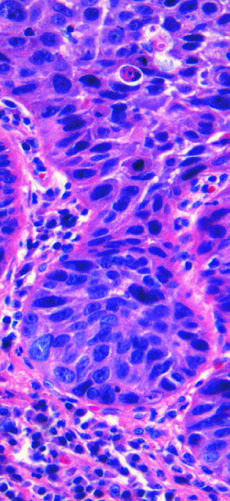what is composed of nests of malignant cells that partially recapitulate the stratified organization of squamous epithelium?
Answer the question using a single word or phrase. Squamous cell carcinoma 